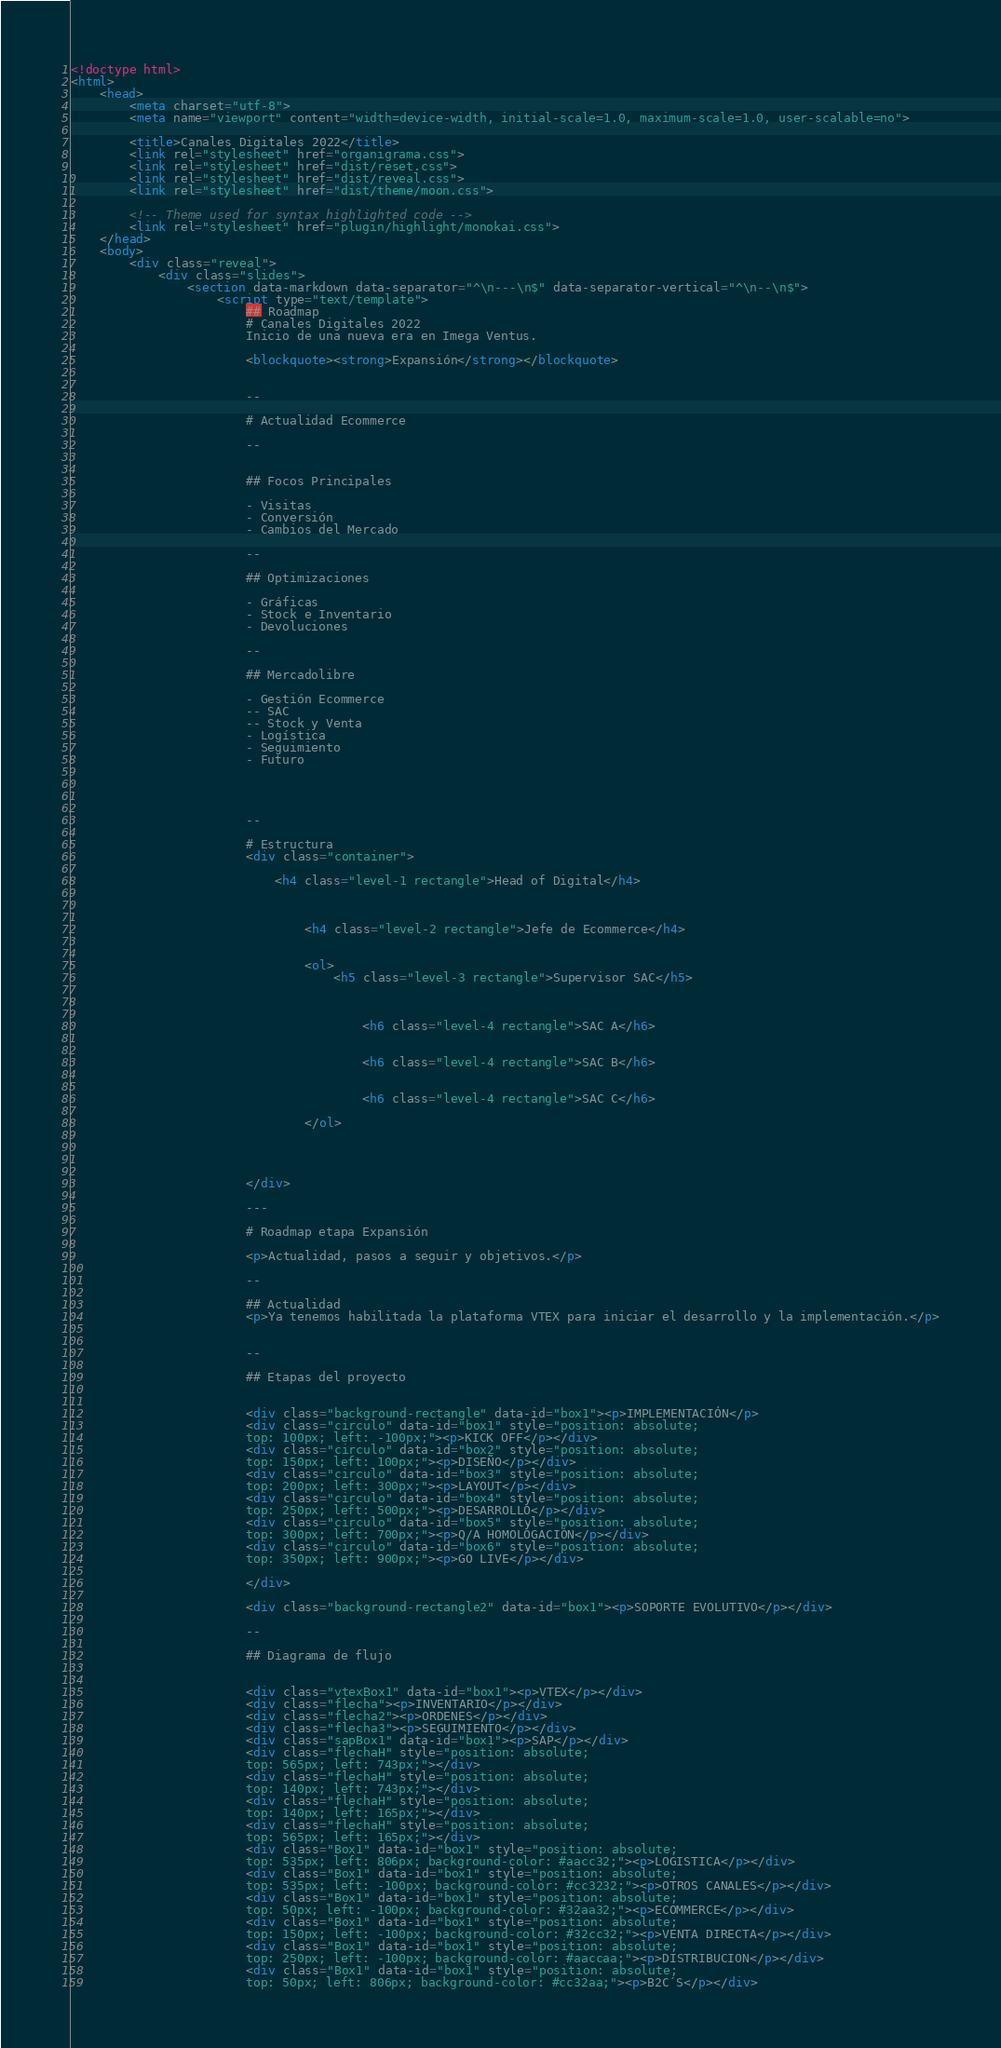Convert code to text. <code><loc_0><loc_0><loc_500><loc_500><_HTML_><!doctype html>
<html>
	<head>
		<meta charset="utf-8">
		<meta name="viewport" content="width=device-width, initial-scale=1.0, maximum-scale=1.0, user-scalable=no">

		<title>Canales Digitales 2022</title>
		<link rel="stylesheet" href="organigrama.css">
		<link rel="stylesheet" href="dist/reset.css">
		<link rel="stylesheet" href="dist/reveal.css">
		<link rel="stylesheet" href="dist/theme/moon.css">

		<!-- Theme used for syntax highlighted code -->
		<link rel="stylesheet" href="plugin/highlight/monokai.css">
	</head>
	<body>
		<div class="reveal"> 
			<div class="slides">
                <section data-markdown data-separator="^\n---\n$" data-separator-vertical="^\n--\n$">
                    <script type="text/template">
                        ## Roadmap 
                        # Canales Digitales 2022
                        Inicio de una nueva era en Imega Ventus.

                        <blockquote><strong>Expansión</strong></blockquote>
                       

                        --

                        # Actualidad Ecommerce

                        --
                        
                            
                        ## Focos Principales

                        - Visitas
                        - Conversión
                        - Cambios del Mercado
                        
                        --
                        
                        ## Optimizaciones

                        - Gráficas
                        - Stock e Inventario
                        - Devoluciones

                        --

                        ## Mercadolibre

                        - Gestión Ecommerce
                        -- SAC
                        -- Stock y Venta
                        - Logística
                        - Seguimiento
                        - Futuro
                            
                        


                        --

                        # Estructura
                        <div class="container">
                            
                            <h4 class="level-1 rectangle">Head of Digital</h4>
                            
                            
                              
                                <h4 class="level-2 rectangle">Jefe de Ecommerce</h4>
                                
                                
                                <ol>
                                    <h5 class="level-3 rectangle">Supervisor SAC</h5>
                                    
                                            
                                      
                                        <h6 class="level-4 rectangle">SAC A</h6>
                                      
                                      
                                        <h6 class="level-4 rectangle">SAC B</h6>
                                      
                                      
                                        <h6 class="level-4 rectangle">SAC C</h6>
                                        
                                </ol>
                             
                        
                                      
                                    
                        </div>

                        ---

                        # Roadmap etapa Expansión

                        <p>Actualidad, pasos a seguir y objetivos.</p>

                        --

                        ## Actualidad
                        <p>Ya tenemos habilitada la plataforma VTEX para iniciar el desarrollo y la implementación.</p>


                        --

                        ## Etapas del proyecto

                        
                        <div class="background-rectangle" data-id="box1"><p>IMPLEMENTACIÓN</p>
                        <div class="circulo" data-id="box1" style="position: absolute;
                        top: 100px; left: -100px;"><p>KICK OFF</p></div>
                        <div class="circulo" data-id="box2" style="position: absolute;
                        top: 150px; left: 100px;"><p>DISEÑO</p></div>
                        <div class="circulo" data-id="box3" style="position: absolute;
                        top: 200px; left: 300px;"><p>LAYOUT</p></div>
                        <div class="circulo" data-id="box4" style="position: absolute;
                        top: 250px; left: 500px;"><p>DESARROLLO</p></div>
                        <div class="circulo" data-id="box5" style="position: absolute;
                        top: 300px; left: 700px;"><p>Q/A HOMOLOGACIÓN</p></div>
                        <div class="circulo" data-id="box6" style="position: absolute;
                        top: 350px; left: 900px;"><p>GO LIVE</p></div>
                        
                        </div>

                        <div class="background-rectangle2" data-id="box1"><p>SOPORTE EVOLUTIVO</p></div>

                        --

                        ## Diagrama de flujo

                        
                        <div class="vtexBox1" data-id="box1"><p>VTEX</p></div>
                        <div class="flecha"><p>INVENTARIO</p></div>
                        <div class="flecha2"><p>ORDENES</p></div>
                        <div class="flecha3"><p>SEGUIMIENTO</p></div>
                        <div class="sapBox1" data-id="box1"><p>SAP</p></div>
                        <div class="flechaH" style="position: absolute;
                        top: 565px; left: 743px;"></div>
                        <div class="flechaH" style="position: absolute;
                        top: 140px; left: 743px;"></div>
                        <div class="flechaH" style="position: absolute;
                        top: 140px; left: 165px;"></div>
                        <div class="flechaH" style="position: absolute;
                        top: 565px; left: 165px;"></div>
                        <div class="Box1" data-id="box1" style="position: absolute;
                        top: 535px; left: 806px; background-color: #aacc32;"><p>LOGISTICA</p></div>
                        <div class="Box1" data-id="box1" style="position: absolute;
                        top: 535px; left: -100px; background-color: #cc3232;"><p>OTROS CANALES</p></div>
                        <div class="Box1" data-id="box1" style="position: absolute;
                        top: 50px; left: -100px; background-color: #32aa32;"><p>ECOMMERCE</p></div>
                        <div class="Box1" data-id="box1" style="position: absolute;
                        top: 150px; left: -100px; background-color: #32cc32;"><p>VENTA DIRECTA</p></div>
                        <div class="Box1" data-id="box1" style="position: absolute;
                        top: 250px; left: -100px; background-color: #aaccaa;"><p>DISTRIBUCION</p></div>
                        <div class="Box1" data-id="box1" style="position: absolute;
                        top: 50px; left: 806px; background-color: #cc32aa;"><p>B2C´S</p></div></code> 